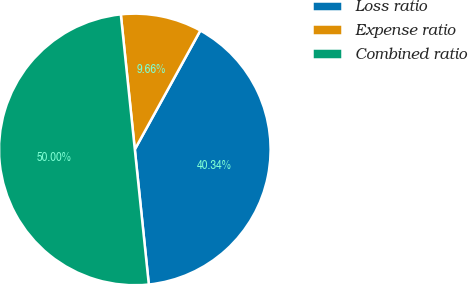Convert chart to OTSL. <chart><loc_0><loc_0><loc_500><loc_500><pie_chart><fcel>Loss ratio<fcel>Expense ratio<fcel>Combined ratio<nl><fcel>40.34%<fcel>9.66%<fcel>50.0%<nl></chart> 